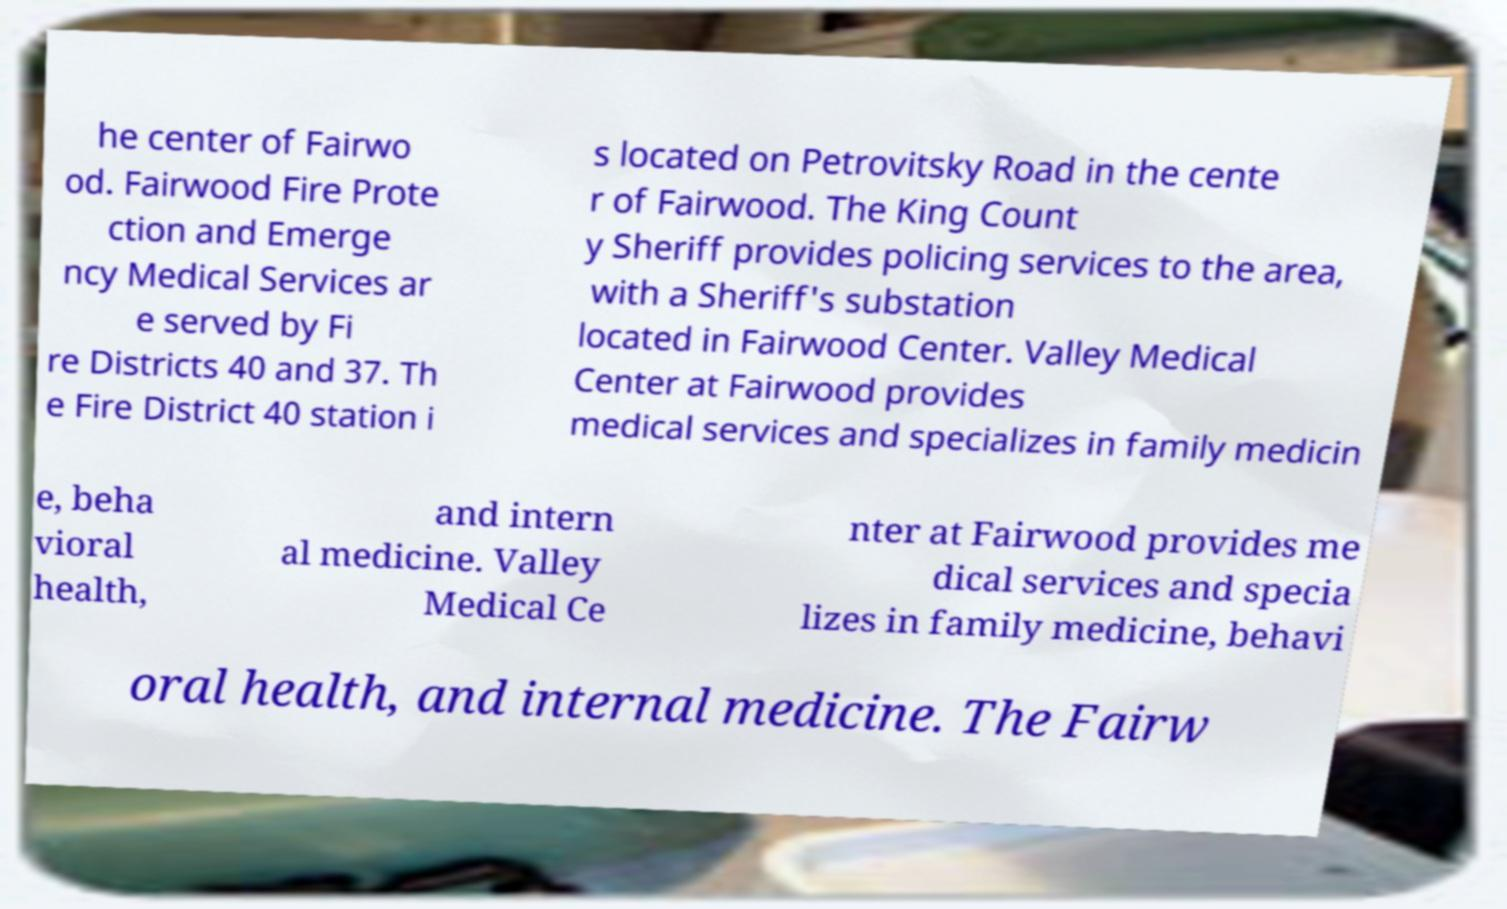Can you read and provide the text displayed in the image?This photo seems to have some interesting text. Can you extract and type it out for me? he center of Fairwo od. Fairwood Fire Prote ction and Emerge ncy Medical Services ar e served by Fi re Districts 40 and 37. Th e Fire District 40 station i s located on Petrovitsky Road in the cente r of Fairwood. The King Count y Sheriff provides policing services to the area, with a Sheriff's substation located in Fairwood Center. Valley Medical Center at Fairwood provides medical services and specializes in family medicin e, beha vioral health, and intern al medicine. Valley Medical Ce nter at Fairwood provides me dical services and specia lizes in family medicine, behavi oral health, and internal medicine. The Fairw 